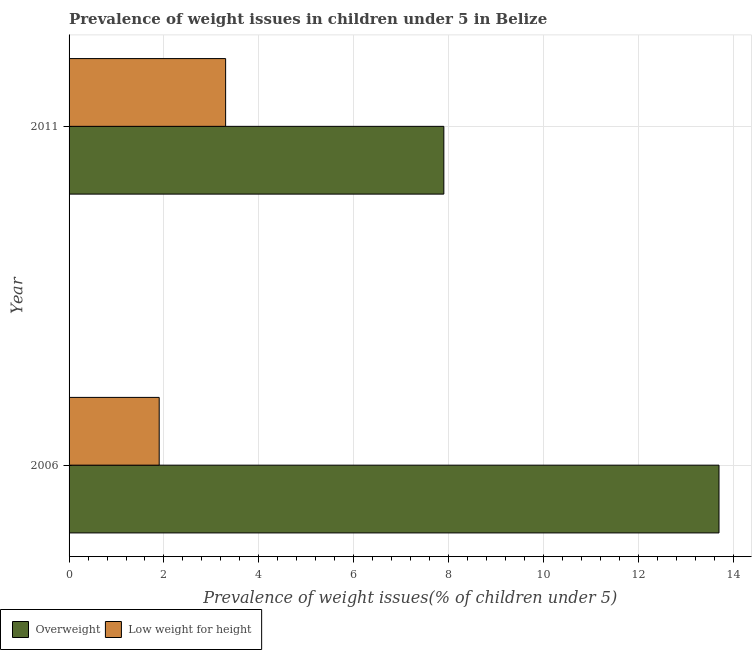How many groups of bars are there?
Provide a succinct answer. 2. Are the number of bars on each tick of the Y-axis equal?
Your answer should be compact. Yes. How many bars are there on the 2nd tick from the top?
Offer a terse response. 2. How many bars are there on the 1st tick from the bottom?
Provide a succinct answer. 2. What is the label of the 1st group of bars from the top?
Offer a very short reply. 2011. In how many cases, is the number of bars for a given year not equal to the number of legend labels?
Your answer should be very brief. 0. What is the percentage of overweight children in 2006?
Give a very brief answer. 13.7. Across all years, what is the maximum percentage of overweight children?
Your answer should be very brief. 13.7. Across all years, what is the minimum percentage of underweight children?
Offer a very short reply. 1.9. What is the total percentage of overweight children in the graph?
Your response must be concise. 21.6. What is the difference between the percentage of underweight children in 2006 and that in 2011?
Offer a very short reply. -1.4. What is the difference between the percentage of overweight children in 2011 and the percentage of underweight children in 2006?
Offer a very short reply. 6. What is the ratio of the percentage of underweight children in 2006 to that in 2011?
Ensure brevity in your answer.  0.58. In how many years, is the percentage of overweight children greater than the average percentage of overweight children taken over all years?
Your answer should be compact. 1. What does the 2nd bar from the top in 2011 represents?
Offer a very short reply. Overweight. What does the 1st bar from the bottom in 2011 represents?
Give a very brief answer. Overweight. How many bars are there?
Give a very brief answer. 4. What is the difference between two consecutive major ticks on the X-axis?
Ensure brevity in your answer.  2. Are the values on the major ticks of X-axis written in scientific E-notation?
Provide a short and direct response. No. Does the graph contain grids?
Give a very brief answer. Yes. What is the title of the graph?
Offer a terse response. Prevalence of weight issues in children under 5 in Belize. What is the label or title of the X-axis?
Offer a terse response. Prevalence of weight issues(% of children under 5). What is the Prevalence of weight issues(% of children under 5) in Overweight in 2006?
Your response must be concise. 13.7. What is the Prevalence of weight issues(% of children under 5) of Low weight for height in 2006?
Give a very brief answer. 1.9. What is the Prevalence of weight issues(% of children under 5) of Overweight in 2011?
Your response must be concise. 7.9. What is the Prevalence of weight issues(% of children under 5) in Low weight for height in 2011?
Provide a succinct answer. 3.3. Across all years, what is the maximum Prevalence of weight issues(% of children under 5) of Overweight?
Ensure brevity in your answer.  13.7. Across all years, what is the maximum Prevalence of weight issues(% of children under 5) in Low weight for height?
Keep it short and to the point. 3.3. Across all years, what is the minimum Prevalence of weight issues(% of children under 5) in Overweight?
Your answer should be very brief. 7.9. Across all years, what is the minimum Prevalence of weight issues(% of children under 5) of Low weight for height?
Offer a terse response. 1.9. What is the total Prevalence of weight issues(% of children under 5) of Overweight in the graph?
Ensure brevity in your answer.  21.6. What is the difference between the Prevalence of weight issues(% of children under 5) in Overweight in 2006 and that in 2011?
Your answer should be very brief. 5.8. What is the difference between the Prevalence of weight issues(% of children under 5) in Low weight for height in 2006 and that in 2011?
Provide a short and direct response. -1.4. What is the difference between the Prevalence of weight issues(% of children under 5) of Overweight in 2006 and the Prevalence of weight issues(% of children under 5) of Low weight for height in 2011?
Give a very brief answer. 10.4. What is the average Prevalence of weight issues(% of children under 5) of Overweight per year?
Your answer should be very brief. 10.8. In the year 2006, what is the difference between the Prevalence of weight issues(% of children under 5) of Overweight and Prevalence of weight issues(% of children under 5) of Low weight for height?
Your answer should be very brief. 11.8. In the year 2011, what is the difference between the Prevalence of weight issues(% of children under 5) in Overweight and Prevalence of weight issues(% of children under 5) in Low weight for height?
Ensure brevity in your answer.  4.6. What is the ratio of the Prevalence of weight issues(% of children under 5) in Overweight in 2006 to that in 2011?
Provide a short and direct response. 1.73. What is the ratio of the Prevalence of weight issues(% of children under 5) in Low weight for height in 2006 to that in 2011?
Your answer should be compact. 0.58. What is the difference between the highest and the second highest Prevalence of weight issues(% of children under 5) of Low weight for height?
Make the answer very short. 1.4. What is the difference between the highest and the lowest Prevalence of weight issues(% of children under 5) in Overweight?
Make the answer very short. 5.8. 